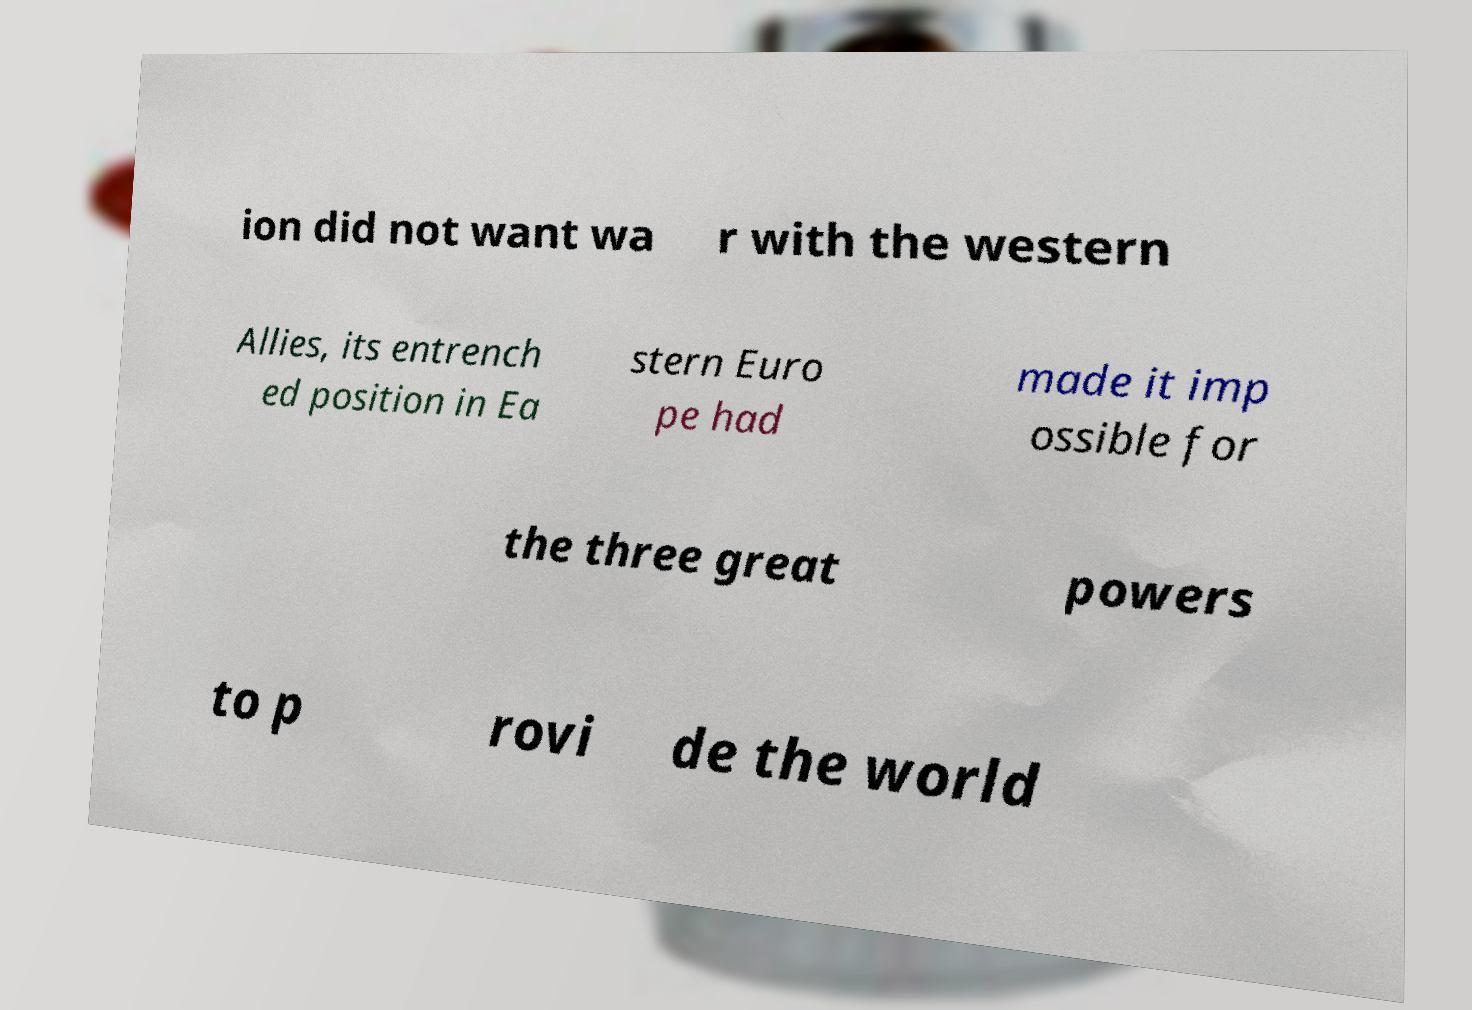I need the written content from this picture converted into text. Can you do that? ion did not want wa r with the western Allies, its entrench ed position in Ea stern Euro pe had made it imp ossible for the three great powers to p rovi de the world 